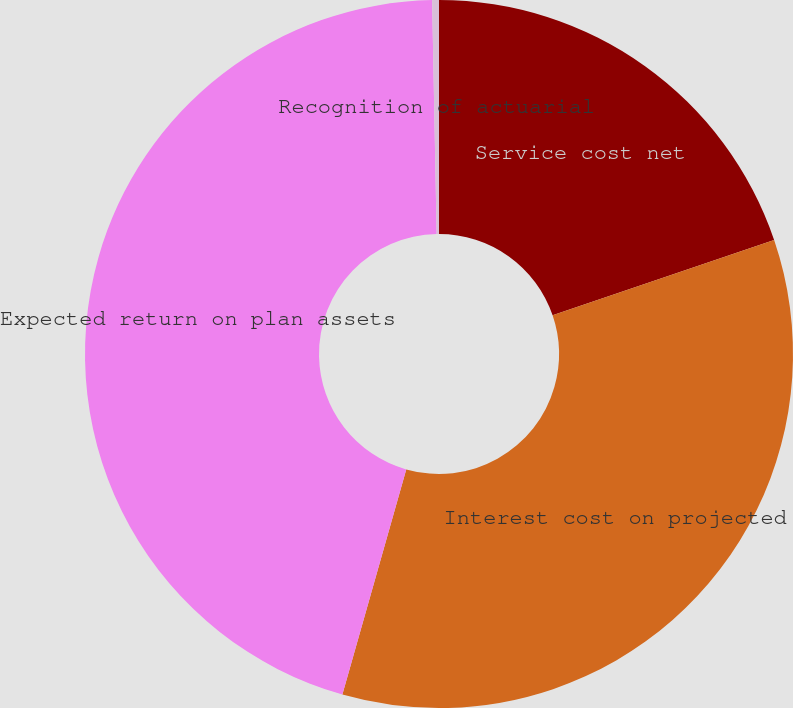<chart> <loc_0><loc_0><loc_500><loc_500><pie_chart><fcel>Service cost net<fcel>Interest cost on projected<fcel>Expected return on plan assets<fcel>Recognition of actuarial<nl><fcel>19.78%<fcel>34.62%<fcel>45.29%<fcel>0.31%<nl></chart> 